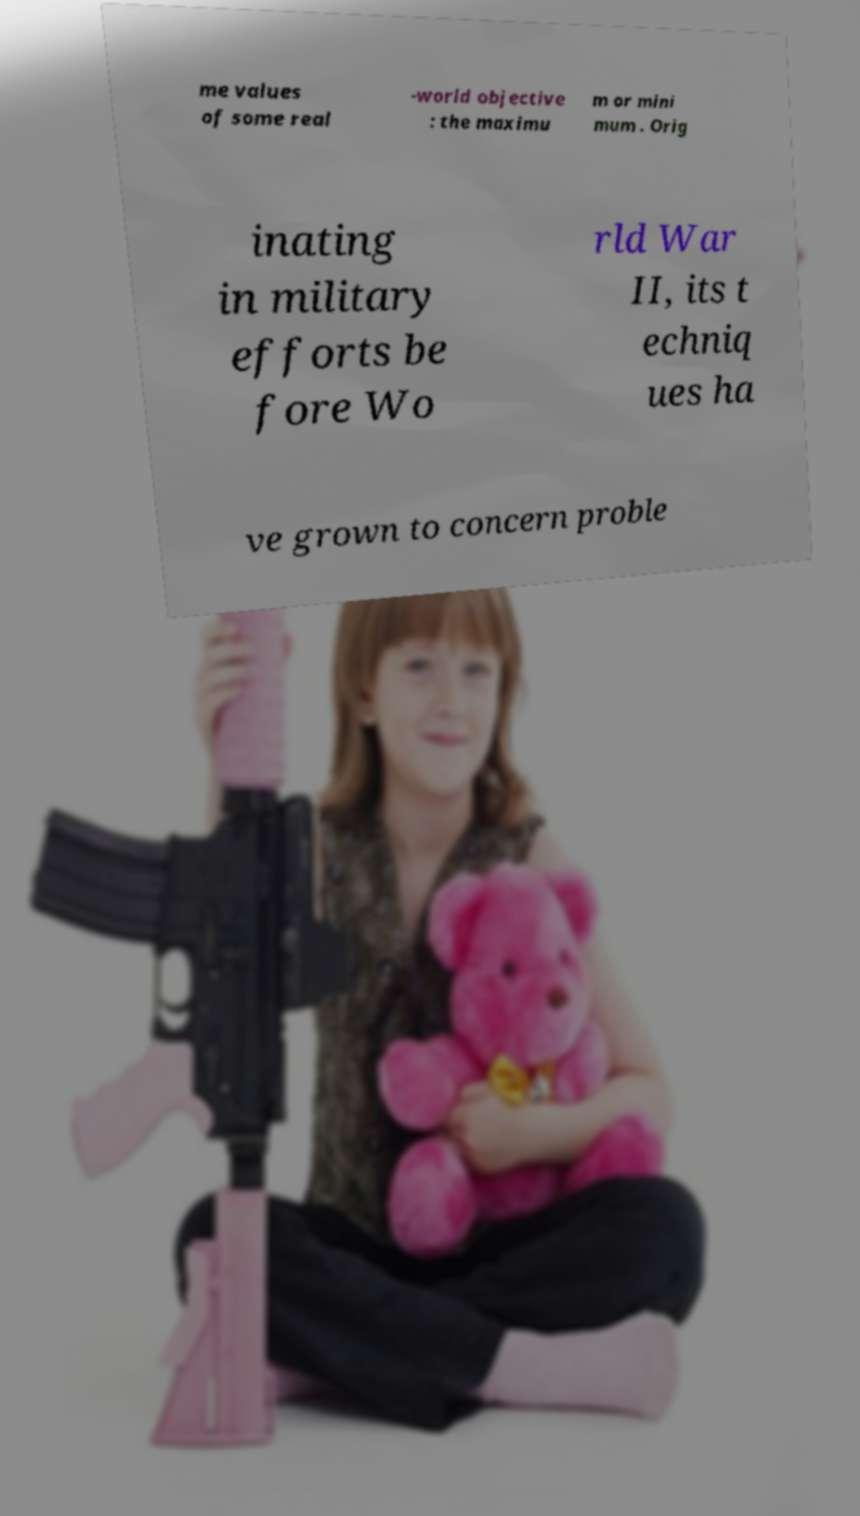Could you assist in decoding the text presented in this image and type it out clearly? me values of some real -world objective : the maximu m or mini mum . Orig inating in military efforts be fore Wo rld War II, its t echniq ues ha ve grown to concern proble 